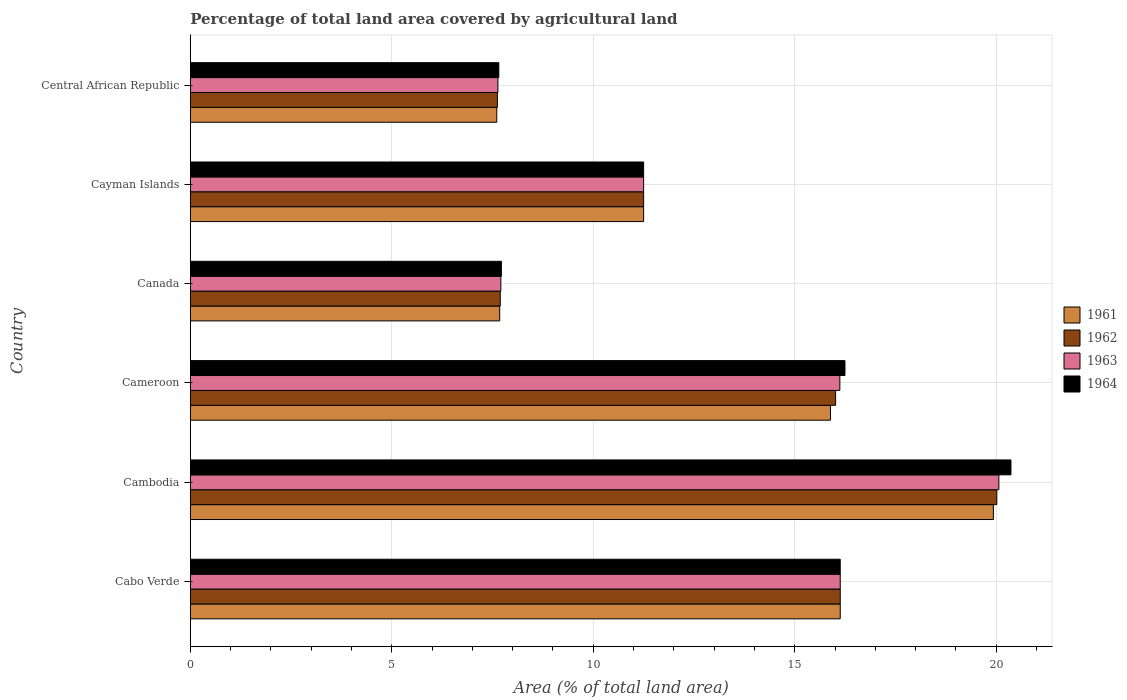How many groups of bars are there?
Offer a very short reply. 6. What is the label of the 3rd group of bars from the top?
Ensure brevity in your answer.  Canada. In how many cases, is the number of bars for a given country not equal to the number of legend labels?
Keep it short and to the point. 0. What is the percentage of agricultural land in 1963 in Cambodia?
Offer a very short reply. 20.07. Across all countries, what is the maximum percentage of agricultural land in 1961?
Keep it short and to the point. 19.93. Across all countries, what is the minimum percentage of agricultural land in 1962?
Your answer should be very brief. 7.62. In which country was the percentage of agricultural land in 1961 maximum?
Your answer should be very brief. Cambodia. In which country was the percentage of agricultural land in 1962 minimum?
Ensure brevity in your answer.  Central African Republic. What is the total percentage of agricultural land in 1963 in the graph?
Your response must be concise. 78.91. What is the difference between the percentage of agricultural land in 1961 in Cambodia and that in Cayman Islands?
Provide a succinct answer. 8.68. What is the difference between the percentage of agricultural land in 1962 in Cambodia and the percentage of agricultural land in 1961 in Central African Republic?
Your answer should be very brief. 12.41. What is the average percentage of agricultural land in 1961 per country?
Your answer should be compact. 13.08. What is the difference between the percentage of agricultural land in 1964 and percentage of agricultural land in 1963 in Cayman Islands?
Offer a terse response. 0. In how many countries, is the percentage of agricultural land in 1961 greater than 19 %?
Your answer should be very brief. 1. What is the ratio of the percentage of agricultural land in 1964 in Cameroon to that in Canada?
Offer a very short reply. 2.1. Is the percentage of agricultural land in 1963 in Cameroon less than that in Cayman Islands?
Offer a very short reply. No. What is the difference between the highest and the second highest percentage of agricultural land in 1963?
Your answer should be compact. 3.94. What is the difference between the highest and the lowest percentage of agricultural land in 1963?
Keep it short and to the point. 12.43. Is the sum of the percentage of agricultural land in 1964 in Cambodia and Canada greater than the maximum percentage of agricultural land in 1961 across all countries?
Your answer should be very brief. Yes. Is it the case that in every country, the sum of the percentage of agricultural land in 1961 and percentage of agricultural land in 1962 is greater than the sum of percentage of agricultural land in 1964 and percentage of agricultural land in 1963?
Make the answer very short. No. What does the 4th bar from the bottom in Cayman Islands represents?
Make the answer very short. 1964. Is it the case that in every country, the sum of the percentage of agricultural land in 1962 and percentage of agricultural land in 1961 is greater than the percentage of agricultural land in 1964?
Provide a succinct answer. Yes. How many bars are there?
Your response must be concise. 24. Are all the bars in the graph horizontal?
Provide a succinct answer. Yes. What is the difference between two consecutive major ticks on the X-axis?
Provide a succinct answer. 5. Does the graph contain any zero values?
Offer a terse response. No. Where does the legend appear in the graph?
Ensure brevity in your answer.  Center right. How many legend labels are there?
Offer a very short reply. 4. How are the legend labels stacked?
Provide a succinct answer. Vertical. What is the title of the graph?
Your response must be concise. Percentage of total land area covered by agricultural land. What is the label or title of the X-axis?
Make the answer very short. Area (% of total land area). What is the label or title of the Y-axis?
Keep it short and to the point. Country. What is the Area (% of total land area) of 1961 in Cabo Verde?
Offer a very short reply. 16.13. What is the Area (% of total land area) of 1962 in Cabo Verde?
Ensure brevity in your answer.  16.13. What is the Area (% of total land area) of 1963 in Cabo Verde?
Make the answer very short. 16.13. What is the Area (% of total land area) of 1964 in Cabo Verde?
Your response must be concise. 16.13. What is the Area (% of total land area) of 1961 in Cambodia?
Ensure brevity in your answer.  19.93. What is the Area (% of total land area) of 1962 in Cambodia?
Ensure brevity in your answer.  20.01. What is the Area (% of total land area) in 1963 in Cambodia?
Make the answer very short. 20.07. What is the Area (% of total land area) of 1964 in Cambodia?
Give a very brief answer. 20.37. What is the Area (% of total land area) of 1961 in Cameroon?
Ensure brevity in your answer.  15.89. What is the Area (% of total land area) in 1962 in Cameroon?
Provide a short and direct response. 16.01. What is the Area (% of total land area) in 1963 in Cameroon?
Ensure brevity in your answer.  16.12. What is the Area (% of total land area) in 1964 in Cameroon?
Keep it short and to the point. 16.25. What is the Area (% of total land area) of 1961 in Canada?
Offer a very short reply. 7.68. What is the Area (% of total land area) in 1962 in Canada?
Offer a terse response. 7.69. What is the Area (% of total land area) in 1963 in Canada?
Give a very brief answer. 7.71. What is the Area (% of total land area) in 1964 in Canada?
Keep it short and to the point. 7.72. What is the Area (% of total land area) of 1961 in Cayman Islands?
Your answer should be very brief. 11.25. What is the Area (% of total land area) of 1962 in Cayman Islands?
Offer a very short reply. 11.25. What is the Area (% of total land area) of 1963 in Cayman Islands?
Your response must be concise. 11.25. What is the Area (% of total land area) of 1964 in Cayman Islands?
Provide a succinct answer. 11.25. What is the Area (% of total land area) in 1961 in Central African Republic?
Keep it short and to the point. 7.61. What is the Area (% of total land area) in 1962 in Central African Republic?
Keep it short and to the point. 7.62. What is the Area (% of total land area) of 1963 in Central African Republic?
Give a very brief answer. 7.63. What is the Area (% of total land area) of 1964 in Central African Republic?
Offer a very short reply. 7.66. Across all countries, what is the maximum Area (% of total land area) in 1961?
Give a very brief answer. 19.93. Across all countries, what is the maximum Area (% of total land area) of 1962?
Keep it short and to the point. 20.01. Across all countries, what is the maximum Area (% of total land area) in 1963?
Make the answer very short. 20.07. Across all countries, what is the maximum Area (% of total land area) of 1964?
Offer a terse response. 20.37. Across all countries, what is the minimum Area (% of total land area) of 1961?
Give a very brief answer. 7.61. Across all countries, what is the minimum Area (% of total land area) in 1962?
Your answer should be very brief. 7.62. Across all countries, what is the minimum Area (% of total land area) of 1963?
Your answer should be compact. 7.63. Across all countries, what is the minimum Area (% of total land area) in 1964?
Provide a succinct answer. 7.66. What is the total Area (% of total land area) of 1961 in the graph?
Your answer should be compact. 78.48. What is the total Area (% of total land area) of 1962 in the graph?
Your answer should be compact. 78.72. What is the total Area (% of total land area) in 1963 in the graph?
Provide a succinct answer. 78.91. What is the total Area (% of total land area) of 1964 in the graph?
Your answer should be compact. 79.37. What is the difference between the Area (% of total land area) in 1961 in Cabo Verde and that in Cambodia?
Your response must be concise. -3.8. What is the difference between the Area (% of total land area) of 1962 in Cabo Verde and that in Cambodia?
Provide a succinct answer. -3.89. What is the difference between the Area (% of total land area) of 1963 in Cabo Verde and that in Cambodia?
Your answer should be very brief. -3.94. What is the difference between the Area (% of total land area) of 1964 in Cabo Verde and that in Cambodia?
Offer a terse response. -4.24. What is the difference between the Area (% of total land area) in 1961 in Cabo Verde and that in Cameroon?
Ensure brevity in your answer.  0.24. What is the difference between the Area (% of total land area) in 1962 in Cabo Verde and that in Cameroon?
Offer a very short reply. 0.12. What is the difference between the Area (% of total land area) in 1963 in Cabo Verde and that in Cameroon?
Make the answer very short. 0.01. What is the difference between the Area (% of total land area) of 1964 in Cabo Verde and that in Cameroon?
Give a very brief answer. -0.12. What is the difference between the Area (% of total land area) in 1961 in Cabo Verde and that in Canada?
Give a very brief answer. 8.45. What is the difference between the Area (% of total land area) of 1962 in Cabo Verde and that in Canada?
Ensure brevity in your answer.  8.44. What is the difference between the Area (% of total land area) in 1963 in Cabo Verde and that in Canada?
Make the answer very short. 8.42. What is the difference between the Area (% of total land area) of 1964 in Cabo Verde and that in Canada?
Provide a succinct answer. 8.41. What is the difference between the Area (% of total land area) of 1961 in Cabo Verde and that in Cayman Islands?
Offer a terse response. 4.88. What is the difference between the Area (% of total land area) of 1962 in Cabo Verde and that in Cayman Islands?
Your answer should be very brief. 4.88. What is the difference between the Area (% of total land area) of 1963 in Cabo Verde and that in Cayman Islands?
Make the answer very short. 4.88. What is the difference between the Area (% of total land area) of 1964 in Cabo Verde and that in Cayman Islands?
Give a very brief answer. 4.88. What is the difference between the Area (% of total land area) in 1961 in Cabo Verde and that in Central African Republic?
Offer a terse response. 8.52. What is the difference between the Area (% of total land area) in 1962 in Cabo Verde and that in Central African Republic?
Offer a terse response. 8.51. What is the difference between the Area (% of total land area) of 1963 in Cabo Verde and that in Central African Republic?
Provide a short and direct response. 8.49. What is the difference between the Area (% of total land area) of 1964 in Cabo Verde and that in Central African Republic?
Your answer should be compact. 8.47. What is the difference between the Area (% of total land area) in 1961 in Cambodia and that in Cameroon?
Offer a very short reply. 4.04. What is the difference between the Area (% of total land area) in 1962 in Cambodia and that in Cameroon?
Give a very brief answer. 4. What is the difference between the Area (% of total land area) of 1963 in Cambodia and that in Cameroon?
Your response must be concise. 3.95. What is the difference between the Area (% of total land area) in 1964 in Cambodia and that in Cameroon?
Your response must be concise. 4.12. What is the difference between the Area (% of total land area) in 1961 in Cambodia and that in Canada?
Offer a very short reply. 12.25. What is the difference between the Area (% of total land area) of 1962 in Cambodia and that in Canada?
Make the answer very short. 12.32. What is the difference between the Area (% of total land area) of 1963 in Cambodia and that in Canada?
Your response must be concise. 12.36. What is the difference between the Area (% of total land area) in 1964 in Cambodia and that in Canada?
Provide a succinct answer. 12.65. What is the difference between the Area (% of total land area) of 1961 in Cambodia and that in Cayman Islands?
Ensure brevity in your answer.  8.68. What is the difference between the Area (% of total land area) of 1962 in Cambodia and that in Cayman Islands?
Provide a short and direct response. 8.76. What is the difference between the Area (% of total land area) in 1963 in Cambodia and that in Cayman Islands?
Make the answer very short. 8.82. What is the difference between the Area (% of total land area) of 1964 in Cambodia and that in Cayman Islands?
Offer a terse response. 9.12. What is the difference between the Area (% of total land area) in 1961 in Cambodia and that in Central African Republic?
Provide a short and direct response. 12.32. What is the difference between the Area (% of total land area) in 1962 in Cambodia and that in Central African Republic?
Offer a terse response. 12.39. What is the difference between the Area (% of total land area) of 1963 in Cambodia and that in Central African Republic?
Offer a terse response. 12.43. What is the difference between the Area (% of total land area) in 1964 in Cambodia and that in Central African Republic?
Offer a very short reply. 12.71. What is the difference between the Area (% of total land area) of 1961 in Cameroon and that in Canada?
Offer a terse response. 8.21. What is the difference between the Area (% of total land area) in 1962 in Cameroon and that in Canada?
Your answer should be very brief. 8.32. What is the difference between the Area (% of total land area) in 1963 in Cameroon and that in Canada?
Your answer should be very brief. 8.41. What is the difference between the Area (% of total land area) in 1964 in Cameroon and that in Canada?
Keep it short and to the point. 8.53. What is the difference between the Area (% of total land area) of 1961 in Cameroon and that in Cayman Islands?
Ensure brevity in your answer.  4.64. What is the difference between the Area (% of total land area) of 1962 in Cameroon and that in Cayman Islands?
Make the answer very short. 4.76. What is the difference between the Area (% of total land area) in 1963 in Cameroon and that in Cayman Islands?
Offer a terse response. 4.87. What is the difference between the Area (% of total land area) in 1964 in Cameroon and that in Cayman Islands?
Offer a terse response. 5. What is the difference between the Area (% of total land area) of 1961 in Cameroon and that in Central African Republic?
Provide a succinct answer. 8.28. What is the difference between the Area (% of total land area) in 1962 in Cameroon and that in Central African Republic?
Your answer should be compact. 8.39. What is the difference between the Area (% of total land area) in 1963 in Cameroon and that in Central African Republic?
Keep it short and to the point. 8.49. What is the difference between the Area (% of total land area) of 1964 in Cameroon and that in Central African Republic?
Provide a succinct answer. 8.59. What is the difference between the Area (% of total land area) of 1961 in Canada and that in Cayman Islands?
Your answer should be very brief. -3.57. What is the difference between the Area (% of total land area) in 1962 in Canada and that in Cayman Islands?
Make the answer very short. -3.56. What is the difference between the Area (% of total land area) in 1963 in Canada and that in Cayman Islands?
Ensure brevity in your answer.  -3.54. What is the difference between the Area (% of total land area) of 1964 in Canada and that in Cayman Islands?
Make the answer very short. -3.53. What is the difference between the Area (% of total land area) of 1961 in Canada and that in Central African Republic?
Offer a very short reply. 0.07. What is the difference between the Area (% of total land area) in 1962 in Canada and that in Central African Republic?
Your answer should be very brief. 0.07. What is the difference between the Area (% of total land area) of 1963 in Canada and that in Central African Republic?
Provide a succinct answer. 0.07. What is the difference between the Area (% of total land area) in 1964 in Canada and that in Central African Republic?
Make the answer very short. 0.06. What is the difference between the Area (% of total land area) of 1961 in Cayman Islands and that in Central African Republic?
Provide a succinct answer. 3.64. What is the difference between the Area (% of total land area) of 1962 in Cayman Islands and that in Central African Republic?
Offer a very short reply. 3.63. What is the difference between the Area (% of total land area) of 1963 in Cayman Islands and that in Central African Republic?
Provide a short and direct response. 3.62. What is the difference between the Area (% of total land area) of 1964 in Cayman Islands and that in Central African Republic?
Make the answer very short. 3.59. What is the difference between the Area (% of total land area) of 1961 in Cabo Verde and the Area (% of total land area) of 1962 in Cambodia?
Provide a short and direct response. -3.89. What is the difference between the Area (% of total land area) in 1961 in Cabo Verde and the Area (% of total land area) in 1963 in Cambodia?
Your answer should be compact. -3.94. What is the difference between the Area (% of total land area) in 1961 in Cabo Verde and the Area (% of total land area) in 1964 in Cambodia?
Keep it short and to the point. -4.24. What is the difference between the Area (% of total land area) in 1962 in Cabo Verde and the Area (% of total land area) in 1963 in Cambodia?
Provide a short and direct response. -3.94. What is the difference between the Area (% of total land area) of 1962 in Cabo Verde and the Area (% of total land area) of 1964 in Cambodia?
Give a very brief answer. -4.24. What is the difference between the Area (% of total land area) of 1963 in Cabo Verde and the Area (% of total land area) of 1964 in Cambodia?
Keep it short and to the point. -4.24. What is the difference between the Area (% of total land area) in 1961 in Cabo Verde and the Area (% of total land area) in 1962 in Cameroon?
Provide a short and direct response. 0.12. What is the difference between the Area (% of total land area) in 1961 in Cabo Verde and the Area (% of total land area) in 1963 in Cameroon?
Offer a very short reply. 0.01. What is the difference between the Area (% of total land area) of 1961 in Cabo Verde and the Area (% of total land area) of 1964 in Cameroon?
Keep it short and to the point. -0.12. What is the difference between the Area (% of total land area) of 1962 in Cabo Verde and the Area (% of total land area) of 1963 in Cameroon?
Ensure brevity in your answer.  0.01. What is the difference between the Area (% of total land area) in 1962 in Cabo Verde and the Area (% of total land area) in 1964 in Cameroon?
Your answer should be very brief. -0.12. What is the difference between the Area (% of total land area) of 1963 in Cabo Verde and the Area (% of total land area) of 1964 in Cameroon?
Give a very brief answer. -0.12. What is the difference between the Area (% of total land area) of 1961 in Cabo Verde and the Area (% of total land area) of 1962 in Canada?
Your answer should be compact. 8.44. What is the difference between the Area (% of total land area) in 1961 in Cabo Verde and the Area (% of total land area) in 1963 in Canada?
Make the answer very short. 8.42. What is the difference between the Area (% of total land area) of 1961 in Cabo Verde and the Area (% of total land area) of 1964 in Canada?
Offer a very short reply. 8.41. What is the difference between the Area (% of total land area) of 1962 in Cabo Verde and the Area (% of total land area) of 1963 in Canada?
Offer a terse response. 8.42. What is the difference between the Area (% of total land area) of 1962 in Cabo Verde and the Area (% of total land area) of 1964 in Canada?
Give a very brief answer. 8.41. What is the difference between the Area (% of total land area) in 1963 in Cabo Verde and the Area (% of total land area) in 1964 in Canada?
Give a very brief answer. 8.41. What is the difference between the Area (% of total land area) in 1961 in Cabo Verde and the Area (% of total land area) in 1962 in Cayman Islands?
Ensure brevity in your answer.  4.88. What is the difference between the Area (% of total land area) in 1961 in Cabo Verde and the Area (% of total land area) in 1963 in Cayman Islands?
Provide a short and direct response. 4.88. What is the difference between the Area (% of total land area) of 1961 in Cabo Verde and the Area (% of total land area) of 1964 in Cayman Islands?
Give a very brief answer. 4.88. What is the difference between the Area (% of total land area) in 1962 in Cabo Verde and the Area (% of total land area) in 1963 in Cayman Islands?
Provide a succinct answer. 4.88. What is the difference between the Area (% of total land area) in 1962 in Cabo Verde and the Area (% of total land area) in 1964 in Cayman Islands?
Ensure brevity in your answer.  4.88. What is the difference between the Area (% of total land area) of 1963 in Cabo Verde and the Area (% of total land area) of 1964 in Cayman Islands?
Provide a succinct answer. 4.88. What is the difference between the Area (% of total land area) in 1961 in Cabo Verde and the Area (% of total land area) in 1962 in Central African Republic?
Your answer should be very brief. 8.51. What is the difference between the Area (% of total land area) in 1961 in Cabo Verde and the Area (% of total land area) in 1963 in Central African Republic?
Your answer should be very brief. 8.49. What is the difference between the Area (% of total land area) of 1961 in Cabo Verde and the Area (% of total land area) of 1964 in Central African Republic?
Give a very brief answer. 8.47. What is the difference between the Area (% of total land area) in 1962 in Cabo Verde and the Area (% of total land area) in 1963 in Central African Republic?
Give a very brief answer. 8.49. What is the difference between the Area (% of total land area) in 1962 in Cabo Verde and the Area (% of total land area) in 1964 in Central African Republic?
Provide a short and direct response. 8.47. What is the difference between the Area (% of total land area) of 1963 in Cabo Verde and the Area (% of total land area) of 1964 in Central African Republic?
Provide a succinct answer. 8.47. What is the difference between the Area (% of total land area) in 1961 in Cambodia and the Area (% of total land area) in 1962 in Cameroon?
Offer a very short reply. 3.92. What is the difference between the Area (% of total land area) of 1961 in Cambodia and the Area (% of total land area) of 1963 in Cameroon?
Offer a very short reply. 3.81. What is the difference between the Area (% of total land area) in 1961 in Cambodia and the Area (% of total land area) in 1964 in Cameroon?
Provide a short and direct response. 3.68. What is the difference between the Area (% of total land area) of 1962 in Cambodia and the Area (% of total land area) of 1963 in Cameroon?
Your response must be concise. 3.89. What is the difference between the Area (% of total land area) of 1962 in Cambodia and the Area (% of total land area) of 1964 in Cameroon?
Offer a terse response. 3.77. What is the difference between the Area (% of total land area) of 1963 in Cambodia and the Area (% of total land area) of 1964 in Cameroon?
Give a very brief answer. 3.82. What is the difference between the Area (% of total land area) of 1961 in Cambodia and the Area (% of total land area) of 1962 in Canada?
Keep it short and to the point. 12.24. What is the difference between the Area (% of total land area) of 1961 in Cambodia and the Area (% of total land area) of 1963 in Canada?
Provide a short and direct response. 12.22. What is the difference between the Area (% of total land area) in 1961 in Cambodia and the Area (% of total land area) in 1964 in Canada?
Offer a very short reply. 12.21. What is the difference between the Area (% of total land area) in 1962 in Cambodia and the Area (% of total land area) in 1963 in Canada?
Ensure brevity in your answer.  12.31. What is the difference between the Area (% of total land area) in 1962 in Cambodia and the Area (% of total land area) in 1964 in Canada?
Make the answer very short. 12.29. What is the difference between the Area (% of total land area) of 1963 in Cambodia and the Area (% of total land area) of 1964 in Canada?
Your answer should be very brief. 12.35. What is the difference between the Area (% of total land area) of 1961 in Cambodia and the Area (% of total land area) of 1962 in Cayman Islands?
Provide a succinct answer. 8.68. What is the difference between the Area (% of total land area) in 1961 in Cambodia and the Area (% of total land area) in 1963 in Cayman Islands?
Your response must be concise. 8.68. What is the difference between the Area (% of total land area) of 1961 in Cambodia and the Area (% of total land area) of 1964 in Cayman Islands?
Provide a short and direct response. 8.68. What is the difference between the Area (% of total land area) of 1962 in Cambodia and the Area (% of total land area) of 1963 in Cayman Islands?
Provide a succinct answer. 8.76. What is the difference between the Area (% of total land area) in 1962 in Cambodia and the Area (% of total land area) in 1964 in Cayman Islands?
Your answer should be very brief. 8.76. What is the difference between the Area (% of total land area) in 1963 in Cambodia and the Area (% of total land area) in 1964 in Cayman Islands?
Your response must be concise. 8.82. What is the difference between the Area (% of total land area) in 1961 in Cambodia and the Area (% of total land area) in 1962 in Central African Republic?
Ensure brevity in your answer.  12.31. What is the difference between the Area (% of total land area) of 1961 in Cambodia and the Area (% of total land area) of 1963 in Central African Republic?
Provide a succinct answer. 12.3. What is the difference between the Area (% of total land area) of 1961 in Cambodia and the Area (% of total land area) of 1964 in Central African Republic?
Provide a short and direct response. 12.27. What is the difference between the Area (% of total land area) of 1962 in Cambodia and the Area (% of total land area) of 1963 in Central African Republic?
Keep it short and to the point. 12.38. What is the difference between the Area (% of total land area) of 1962 in Cambodia and the Area (% of total land area) of 1964 in Central African Republic?
Your response must be concise. 12.36. What is the difference between the Area (% of total land area) of 1963 in Cambodia and the Area (% of total land area) of 1964 in Central African Republic?
Provide a short and direct response. 12.41. What is the difference between the Area (% of total land area) in 1961 in Cameroon and the Area (% of total land area) in 1962 in Canada?
Make the answer very short. 8.19. What is the difference between the Area (% of total land area) of 1961 in Cameroon and the Area (% of total land area) of 1963 in Canada?
Offer a terse response. 8.18. What is the difference between the Area (% of total land area) in 1961 in Cameroon and the Area (% of total land area) in 1964 in Canada?
Make the answer very short. 8.17. What is the difference between the Area (% of total land area) of 1962 in Cameroon and the Area (% of total land area) of 1963 in Canada?
Offer a very short reply. 8.31. What is the difference between the Area (% of total land area) of 1962 in Cameroon and the Area (% of total land area) of 1964 in Canada?
Provide a succinct answer. 8.29. What is the difference between the Area (% of total land area) in 1963 in Cameroon and the Area (% of total land area) in 1964 in Canada?
Keep it short and to the point. 8.4. What is the difference between the Area (% of total land area) in 1961 in Cameroon and the Area (% of total land area) in 1962 in Cayman Islands?
Give a very brief answer. 4.64. What is the difference between the Area (% of total land area) of 1961 in Cameroon and the Area (% of total land area) of 1963 in Cayman Islands?
Your answer should be very brief. 4.64. What is the difference between the Area (% of total land area) in 1961 in Cameroon and the Area (% of total land area) in 1964 in Cayman Islands?
Your answer should be very brief. 4.64. What is the difference between the Area (% of total land area) of 1962 in Cameroon and the Area (% of total land area) of 1963 in Cayman Islands?
Your answer should be very brief. 4.76. What is the difference between the Area (% of total land area) of 1962 in Cameroon and the Area (% of total land area) of 1964 in Cayman Islands?
Your answer should be compact. 4.76. What is the difference between the Area (% of total land area) of 1963 in Cameroon and the Area (% of total land area) of 1964 in Cayman Islands?
Your response must be concise. 4.87. What is the difference between the Area (% of total land area) in 1961 in Cameroon and the Area (% of total land area) in 1962 in Central African Republic?
Provide a short and direct response. 8.27. What is the difference between the Area (% of total land area) of 1961 in Cameroon and the Area (% of total land area) of 1963 in Central African Republic?
Make the answer very short. 8.25. What is the difference between the Area (% of total land area) of 1961 in Cameroon and the Area (% of total land area) of 1964 in Central African Republic?
Make the answer very short. 8.23. What is the difference between the Area (% of total land area) of 1962 in Cameroon and the Area (% of total land area) of 1963 in Central African Republic?
Provide a short and direct response. 8.38. What is the difference between the Area (% of total land area) of 1962 in Cameroon and the Area (% of total land area) of 1964 in Central African Republic?
Make the answer very short. 8.36. What is the difference between the Area (% of total land area) in 1963 in Cameroon and the Area (% of total land area) in 1964 in Central African Republic?
Offer a terse response. 8.46. What is the difference between the Area (% of total land area) in 1961 in Canada and the Area (% of total land area) in 1962 in Cayman Islands?
Give a very brief answer. -3.57. What is the difference between the Area (% of total land area) of 1961 in Canada and the Area (% of total land area) of 1963 in Cayman Islands?
Ensure brevity in your answer.  -3.57. What is the difference between the Area (% of total land area) in 1961 in Canada and the Area (% of total land area) in 1964 in Cayman Islands?
Provide a short and direct response. -3.57. What is the difference between the Area (% of total land area) in 1962 in Canada and the Area (% of total land area) in 1963 in Cayman Islands?
Provide a succinct answer. -3.56. What is the difference between the Area (% of total land area) of 1962 in Canada and the Area (% of total land area) of 1964 in Cayman Islands?
Your answer should be very brief. -3.56. What is the difference between the Area (% of total land area) in 1963 in Canada and the Area (% of total land area) in 1964 in Cayman Islands?
Your answer should be very brief. -3.54. What is the difference between the Area (% of total land area) of 1961 in Canada and the Area (% of total land area) of 1962 in Central African Republic?
Your response must be concise. 0.06. What is the difference between the Area (% of total land area) in 1961 in Canada and the Area (% of total land area) in 1963 in Central African Republic?
Your response must be concise. 0.04. What is the difference between the Area (% of total land area) of 1961 in Canada and the Area (% of total land area) of 1964 in Central African Republic?
Provide a short and direct response. 0.02. What is the difference between the Area (% of total land area) in 1962 in Canada and the Area (% of total land area) in 1963 in Central African Republic?
Provide a succinct answer. 0.06. What is the difference between the Area (% of total land area) in 1962 in Canada and the Area (% of total land area) in 1964 in Central African Republic?
Give a very brief answer. 0.04. What is the difference between the Area (% of total land area) in 1961 in Cayman Islands and the Area (% of total land area) in 1962 in Central African Republic?
Your response must be concise. 3.63. What is the difference between the Area (% of total land area) in 1961 in Cayman Islands and the Area (% of total land area) in 1963 in Central African Republic?
Your response must be concise. 3.62. What is the difference between the Area (% of total land area) in 1961 in Cayman Islands and the Area (% of total land area) in 1964 in Central African Republic?
Provide a short and direct response. 3.59. What is the difference between the Area (% of total land area) of 1962 in Cayman Islands and the Area (% of total land area) of 1963 in Central African Republic?
Make the answer very short. 3.62. What is the difference between the Area (% of total land area) in 1962 in Cayman Islands and the Area (% of total land area) in 1964 in Central African Republic?
Give a very brief answer. 3.59. What is the difference between the Area (% of total land area) in 1963 in Cayman Islands and the Area (% of total land area) in 1964 in Central African Republic?
Provide a short and direct response. 3.59. What is the average Area (% of total land area) in 1961 per country?
Keep it short and to the point. 13.08. What is the average Area (% of total land area) in 1962 per country?
Offer a very short reply. 13.12. What is the average Area (% of total land area) of 1963 per country?
Your answer should be compact. 13.15. What is the average Area (% of total land area) in 1964 per country?
Your response must be concise. 13.23. What is the difference between the Area (% of total land area) in 1961 and Area (% of total land area) in 1962 in Cabo Verde?
Offer a very short reply. 0. What is the difference between the Area (% of total land area) of 1961 and Area (% of total land area) of 1963 in Cabo Verde?
Ensure brevity in your answer.  0. What is the difference between the Area (% of total land area) in 1961 and Area (% of total land area) in 1964 in Cabo Verde?
Provide a succinct answer. 0. What is the difference between the Area (% of total land area) in 1962 and Area (% of total land area) in 1964 in Cabo Verde?
Offer a terse response. 0. What is the difference between the Area (% of total land area) in 1963 and Area (% of total land area) in 1964 in Cabo Verde?
Ensure brevity in your answer.  0. What is the difference between the Area (% of total land area) in 1961 and Area (% of total land area) in 1962 in Cambodia?
Offer a very short reply. -0.09. What is the difference between the Area (% of total land area) of 1961 and Area (% of total land area) of 1963 in Cambodia?
Provide a succinct answer. -0.14. What is the difference between the Area (% of total land area) in 1961 and Area (% of total land area) in 1964 in Cambodia?
Your answer should be compact. -0.44. What is the difference between the Area (% of total land area) of 1962 and Area (% of total land area) of 1963 in Cambodia?
Ensure brevity in your answer.  -0.05. What is the difference between the Area (% of total land area) of 1962 and Area (% of total land area) of 1964 in Cambodia?
Make the answer very short. -0.35. What is the difference between the Area (% of total land area) in 1963 and Area (% of total land area) in 1964 in Cambodia?
Offer a very short reply. -0.3. What is the difference between the Area (% of total land area) of 1961 and Area (% of total land area) of 1962 in Cameroon?
Make the answer very short. -0.13. What is the difference between the Area (% of total land area) in 1961 and Area (% of total land area) in 1963 in Cameroon?
Ensure brevity in your answer.  -0.23. What is the difference between the Area (% of total land area) of 1961 and Area (% of total land area) of 1964 in Cameroon?
Make the answer very short. -0.36. What is the difference between the Area (% of total land area) in 1962 and Area (% of total land area) in 1963 in Cameroon?
Your response must be concise. -0.11. What is the difference between the Area (% of total land area) in 1962 and Area (% of total land area) in 1964 in Cameroon?
Keep it short and to the point. -0.23. What is the difference between the Area (% of total land area) of 1963 and Area (% of total land area) of 1964 in Cameroon?
Provide a short and direct response. -0.13. What is the difference between the Area (% of total land area) of 1961 and Area (% of total land area) of 1962 in Canada?
Your answer should be very brief. -0.01. What is the difference between the Area (% of total land area) of 1961 and Area (% of total land area) of 1963 in Canada?
Ensure brevity in your answer.  -0.03. What is the difference between the Area (% of total land area) of 1961 and Area (% of total land area) of 1964 in Canada?
Offer a very short reply. -0.04. What is the difference between the Area (% of total land area) in 1962 and Area (% of total land area) in 1963 in Canada?
Your answer should be compact. -0.01. What is the difference between the Area (% of total land area) in 1962 and Area (% of total land area) in 1964 in Canada?
Give a very brief answer. -0.03. What is the difference between the Area (% of total land area) of 1963 and Area (% of total land area) of 1964 in Canada?
Your answer should be compact. -0.01. What is the difference between the Area (% of total land area) of 1961 and Area (% of total land area) of 1963 in Cayman Islands?
Your answer should be very brief. 0. What is the difference between the Area (% of total land area) of 1961 and Area (% of total land area) of 1964 in Cayman Islands?
Your answer should be compact. 0. What is the difference between the Area (% of total land area) in 1961 and Area (% of total land area) in 1962 in Central African Republic?
Provide a short and direct response. -0.02. What is the difference between the Area (% of total land area) of 1961 and Area (% of total land area) of 1963 in Central African Republic?
Your response must be concise. -0.03. What is the difference between the Area (% of total land area) in 1961 and Area (% of total land area) in 1964 in Central African Republic?
Provide a short and direct response. -0.05. What is the difference between the Area (% of total land area) in 1962 and Area (% of total land area) in 1963 in Central African Republic?
Give a very brief answer. -0.01. What is the difference between the Area (% of total land area) in 1962 and Area (% of total land area) in 1964 in Central African Republic?
Make the answer very short. -0.04. What is the difference between the Area (% of total land area) in 1963 and Area (% of total land area) in 1964 in Central African Republic?
Ensure brevity in your answer.  -0.02. What is the ratio of the Area (% of total land area) in 1961 in Cabo Verde to that in Cambodia?
Keep it short and to the point. 0.81. What is the ratio of the Area (% of total land area) in 1962 in Cabo Verde to that in Cambodia?
Give a very brief answer. 0.81. What is the ratio of the Area (% of total land area) of 1963 in Cabo Verde to that in Cambodia?
Make the answer very short. 0.8. What is the ratio of the Area (% of total land area) of 1964 in Cabo Verde to that in Cambodia?
Offer a terse response. 0.79. What is the ratio of the Area (% of total land area) in 1961 in Cabo Verde to that in Cameroon?
Offer a very short reply. 1.02. What is the ratio of the Area (% of total land area) of 1962 in Cabo Verde to that in Cameroon?
Your response must be concise. 1.01. What is the ratio of the Area (% of total land area) in 1963 in Cabo Verde to that in Cameroon?
Your response must be concise. 1. What is the ratio of the Area (% of total land area) in 1964 in Cabo Verde to that in Cameroon?
Your answer should be very brief. 0.99. What is the ratio of the Area (% of total land area) in 1961 in Cabo Verde to that in Canada?
Make the answer very short. 2.1. What is the ratio of the Area (% of total land area) in 1962 in Cabo Verde to that in Canada?
Keep it short and to the point. 2.1. What is the ratio of the Area (% of total land area) of 1963 in Cabo Verde to that in Canada?
Your answer should be very brief. 2.09. What is the ratio of the Area (% of total land area) in 1964 in Cabo Verde to that in Canada?
Keep it short and to the point. 2.09. What is the ratio of the Area (% of total land area) in 1961 in Cabo Verde to that in Cayman Islands?
Ensure brevity in your answer.  1.43. What is the ratio of the Area (% of total land area) of 1962 in Cabo Verde to that in Cayman Islands?
Your answer should be compact. 1.43. What is the ratio of the Area (% of total land area) of 1963 in Cabo Verde to that in Cayman Islands?
Provide a succinct answer. 1.43. What is the ratio of the Area (% of total land area) in 1964 in Cabo Verde to that in Cayman Islands?
Keep it short and to the point. 1.43. What is the ratio of the Area (% of total land area) of 1961 in Cabo Verde to that in Central African Republic?
Your answer should be compact. 2.12. What is the ratio of the Area (% of total land area) in 1962 in Cabo Verde to that in Central African Republic?
Give a very brief answer. 2.12. What is the ratio of the Area (% of total land area) in 1963 in Cabo Verde to that in Central African Republic?
Offer a very short reply. 2.11. What is the ratio of the Area (% of total land area) in 1964 in Cabo Verde to that in Central African Republic?
Keep it short and to the point. 2.11. What is the ratio of the Area (% of total land area) of 1961 in Cambodia to that in Cameroon?
Offer a very short reply. 1.25. What is the ratio of the Area (% of total land area) of 1962 in Cambodia to that in Cameroon?
Ensure brevity in your answer.  1.25. What is the ratio of the Area (% of total land area) in 1963 in Cambodia to that in Cameroon?
Make the answer very short. 1.24. What is the ratio of the Area (% of total land area) in 1964 in Cambodia to that in Cameroon?
Provide a succinct answer. 1.25. What is the ratio of the Area (% of total land area) of 1961 in Cambodia to that in Canada?
Provide a succinct answer. 2.6. What is the ratio of the Area (% of total land area) of 1962 in Cambodia to that in Canada?
Provide a succinct answer. 2.6. What is the ratio of the Area (% of total land area) of 1963 in Cambodia to that in Canada?
Give a very brief answer. 2.6. What is the ratio of the Area (% of total land area) of 1964 in Cambodia to that in Canada?
Your answer should be compact. 2.64. What is the ratio of the Area (% of total land area) in 1961 in Cambodia to that in Cayman Islands?
Give a very brief answer. 1.77. What is the ratio of the Area (% of total land area) in 1962 in Cambodia to that in Cayman Islands?
Ensure brevity in your answer.  1.78. What is the ratio of the Area (% of total land area) of 1963 in Cambodia to that in Cayman Islands?
Offer a very short reply. 1.78. What is the ratio of the Area (% of total land area) of 1964 in Cambodia to that in Cayman Islands?
Offer a terse response. 1.81. What is the ratio of the Area (% of total land area) in 1961 in Cambodia to that in Central African Republic?
Your answer should be very brief. 2.62. What is the ratio of the Area (% of total land area) in 1962 in Cambodia to that in Central African Republic?
Provide a short and direct response. 2.63. What is the ratio of the Area (% of total land area) of 1963 in Cambodia to that in Central African Republic?
Offer a terse response. 2.63. What is the ratio of the Area (% of total land area) in 1964 in Cambodia to that in Central African Republic?
Ensure brevity in your answer.  2.66. What is the ratio of the Area (% of total land area) in 1961 in Cameroon to that in Canada?
Provide a short and direct response. 2.07. What is the ratio of the Area (% of total land area) in 1962 in Cameroon to that in Canada?
Give a very brief answer. 2.08. What is the ratio of the Area (% of total land area) of 1963 in Cameroon to that in Canada?
Your answer should be compact. 2.09. What is the ratio of the Area (% of total land area) in 1964 in Cameroon to that in Canada?
Give a very brief answer. 2.1. What is the ratio of the Area (% of total land area) in 1961 in Cameroon to that in Cayman Islands?
Give a very brief answer. 1.41. What is the ratio of the Area (% of total land area) of 1962 in Cameroon to that in Cayman Islands?
Give a very brief answer. 1.42. What is the ratio of the Area (% of total land area) of 1963 in Cameroon to that in Cayman Islands?
Your answer should be compact. 1.43. What is the ratio of the Area (% of total land area) in 1964 in Cameroon to that in Cayman Islands?
Offer a terse response. 1.44. What is the ratio of the Area (% of total land area) of 1961 in Cameroon to that in Central African Republic?
Keep it short and to the point. 2.09. What is the ratio of the Area (% of total land area) in 1962 in Cameroon to that in Central African Republic?
Your response must be concise. 2.1. What is the ratio of the Area (% of total land area) of 1963 in Cameroon to that in Central African Republic?
Ensure brevity in your answer.  2.11. What is the ratio of the Area (% of total land area) of 1964 in Cameroon to that in Central African Republic?
Offer a very short reply. 2.12. What is the ratio of the Area (% of total land area) of 1961 in Canada to that in Cayman Islands?
Your answer should be compact. 0.68. What is the ratio of the Area (% of total land area) in 1962 in Canada to that in Cayman Islands?
Offer a very short reply. 0.68. What is the ratio of the Area (% of total land area) of 1963 in Canada to that in Cayman Islands?
Your answer should be very brief. 0.69. What is the ratio of the Area (% of total land area) in 1964 in Canada to that in Cayman Islands?
Offer a very short reply. 0.69. What is the ratio of the Area (% of total land area) in 1961 in Canada to that in Central African Republic?
Ensure brevity in your answer.  1.01. What is the ratio of the Area (% of total land area) of 1962 in Canada to that in Central African Republic?
Keep it short and to the point. 1.01. What is the ratio of the Area (% of total land area) in 1963 in Canada to that in Central African Republic?
Provide a succinct answer. 1.01. What is the ratio of the Area (% of total land area) of 1964 in Canada to that in Central African Republic?
Make the answer very short. 1.01. What is the ratio of the Area (% of total land area) in 1961 in Cayman Islands to that in Central African Republic?
Provide a succinct answer. 1.48. What is the ratio of the Area (% of total land area) of 1962 in Cayman Islands to that in Central African Republic?
Provide a succinct answer. 1.48. What is the ratio of the Area (% of total land area) of 1963 in Cayman Islands to that in Central African Republic?
Offer a very short reply. 1.47. What is the ratio of the Area (% of total land area) of 1964 in Cayman Islands to that in Central African Republic?
Offer a terse response. 1.47. What is the difference between the highest and the second highest Area (% of total land area) of 1961?
Your answer should be compact. 3.8. What is the difference between the highest and the second highest Area (% of total land area) in 1962?
Keep it short and to the point. 3.89. What is the difference between the highest and the second highest Area (% of total land area) in 1963?
Offer a terse response. 3.94. What is the difference between the highest and the second highest Area (% of total land area) in 1964?
Provide a short and direct response. 4.12. What is the difference between the highest and the lowest Area (% of total land area) in 1961?
Provide a succinct answer. 12.32. What is the difference between the highest and the lowest Area (% of total land area) of 1962?
Your response must be concise. 12.39. What is the difference between the highest and the lowest Area (% of total land area) of 1963?
Your answer should be very brief. 12.43. What is the difference between the highest and the lowest Area (% of total land area) of 1964?
Your answer should be very brief. 12.71. 